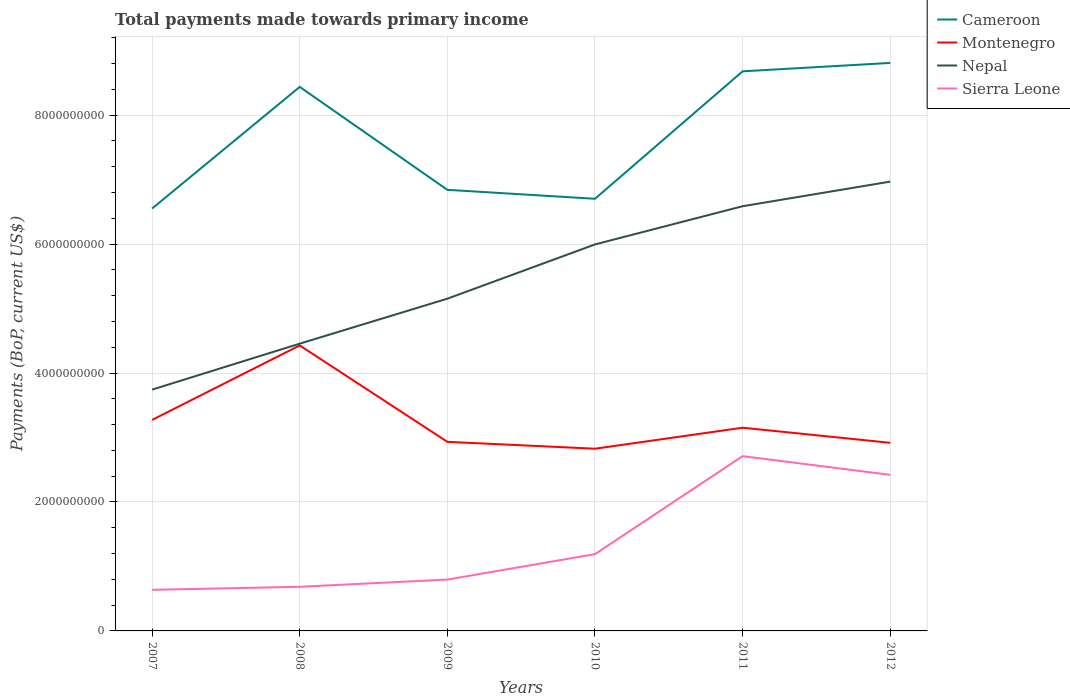How many different coloured lines are there?
Give a very brief answer. 4. Does the line corresponding to Montenegro intersect with the line corresponding to Sierra Leone?
Keep it short and to the point. No. Is the number of lines equal to the number of legend labels?
Provide a short and direct response. Yes. Across all years, what is the maximum total payments made towards primary income in Cameroon?
Keep it short and to the point. 6.55e+09. In which year was the total payments made towards primary income in Nepal maximum?
Offer a very short reply. 2007. What is the total total payments made towards primary income in Nepal in the graph?
Your answer should be compact. -6.98e+08. What is the difference between the highest and the second highest total payments made towards primary income in Montenegro?
Provide a succinct answer. 1.60e+09. Is the total payments made towards primary income in Nepal strictly greater than the total payments made towards primary income in Cameroon over the years?
Your answer should be compact. Yes. How many years are there in the graph?
Provide a succinct answer. 6. What is the difference between two consecutive major ticks on the Y-axis?
Provide a succinct answer. 2.00e+09. Are the values on the major ticks of Y-axis written in scientific E-notation?
Offer a terse response. No. Does the graph contain any zero values?
Ensure brevity in your answer.  No. Where does the legend appear in the graph?
Keep it short and to the point. Top right. What is the title of the graph?
Provide a short and direct response. Total payments made towards primary income. What is the label or title of the X-axis?
Ensure brevity in your answer.  Years. What is the label or title of the Y-axis?
Offer a very short reply. Payments (BoP, current US$). What is the Payments (BoP, current US$) of Cameroon in 2007?
Make the answer very short. 6.55e+09. What is the Payments (BoP, current US$) of Montenegro in 2007?
Keep it short and to the point. 3.27e+09. What is the Payments (BoP, current US$) of Nepal in 2007?
Make the answer very short. 3.74e+09. What is the Payments (BoP, current US$) of Sierra Leone in 2007?
Your answer should be compact. 6.37e+08. What is the Payments (BoP, current US$) in Cameroon in 2008?
Offer a very short reply. 8.44e+09. What is the Payments (BoP, current US$) in Montenegro in 2008?
Provide a short and direct response. 4.43e+09. What is the Payments (BoP, current US$) in Nepal in 2008?
Give a very brief answer. 4.46e+09. What is the Payments (BoP, current US$) of Sierra Leone in 2008?
Provide a short and direct response. 6.85e+08. What is the Payments (BoP, current US$) in Cameroon in 2009?
Offer a very short reply. 6.84e+09. What is the Payments (BoP, current US$) of Montenegro in 2009?
Make the answer very short. 2.93e+09. What is the Payments (BoP, current US$) in Nepal in 2009?
Offer a terse response. 5.15e+09. What is the Payments (BoP, current US$) in Sierra Leone in 2009?
Provide a short and direct response. 7.97e+08. What is the Payments (BoP, current US$) in Cameroon in 2010?
Offer a very short reply. 6.70e+09. What is the Payments (BoP, current US$) of Montenegro in 2010?
Your response must be concise. 2.83e+09. What is the Payments (BoP, current US$) of Nepal in 2010?
Give a very brief answer. 5.99e+09. What is the Payments (BoP, current US$) in Sierra Leone in 2010?
Provide a succinct answer. 1.19e+09. What is the Payments (BoP, current US$) of Cameroon in 2011?
Offer a very short reply. 8.68e+09. What is the Payments (BoP, current US$) in Montenegro in 2011?
Your answer should be compact. 3.15e+09. What is the Payments (BoP, current US$) in Nepal in 2011?
Make the answer very short. 6.59e+09. What is the Payments (BoP, current US$) of Sierra Leone in 2011?
Your answer should be very brief. 2.71e+09. What is the Payments (BoP, current US$) of Cameroon in 2012?
Offer a terse response. 8.81e+09. What is the Payments (BoP, current US$) of Montenegro in 2012?
Make the answer very short. 2.92e+09. What is the Payments (BoP, current US$) of Nepal in 2012?
Offer a very short reply. 6.97e+09. What is the Payments (BoP, current US$) of Sierra Leone in 2012?
Offer a very short reply. 2.42e+09. Across all years, what is the maximum Payments (BoP, current US$) of Cameroon?
Give a very brief answer. 8.81e+09. Across all years, what is the maximum Payments (BoP, current US$) in Montenegro?
Your answer should be compact. 4.43e+09. Across all years, what is the maximum Payments (BoP, current US$) of Nepal?
Offer a terse response. 6.97e+09. Across all years, what is the maximum Payments (BoP, current US$) of Sierra Leone?
Provide a short and direct response. 2.71e+09. Across all years, what is the minimum Payments (BoP, current US$) of Cameroon?
Provide a short and direct response. 6.55e+09. Across all years, what is the minimum Payments (BoP, current US$) of Montenegro?
Make the answer very short. 2.83e+09. Across all years, what is the minimum Payments (BoP, current US$) in Nepal?
Keep it short and to the point. 3.74e+09. Across all years, what is the minimum Payments (BoP, current US$) of Sierra Leone?
Offer a terse response. 6.37e+08. What is the total Payments (BoP, current US$) in Cameroon in the graph?
Make the answer very short. 4.60e+1. What is the total Payments (BoP, current US$) in Montenegro in the graph?
Give a very brief answer. 1.95e+1. What is the total Payments (BoP, current US$) of Nepal in the graph?
Offer a very short reply. 3.29e+1. What is the total Payments (BoP, current US$) in Sierra Leone in the graph?
Your answer should be compact. 8.44e+09. What is the difference between the Payments (BoP, current US$) of Cameroon in 2007 and that in 2008?
Your answer should be compact. -1.89e+09. What is the difference between the Payments (BoP, current US$) of Montenegro in 2007 and that in 2008?
Give a very brief answer. -1.16e+09. What is the difference between the Payments (BoP, current US$) in Nepal in 2007 and that in 2008?
Offer a terse response. -7.13e+08. What is the difference between the Payments (BoP, current US$) in Sierra Leone in 2007 and that in 2008?
Keep it short and to the point. -4.72e+07. What is the difference between the Payments (BoP, current US$) in Cameroon in 2007 and that in 2009?
Your answer should be compact. -2.90e+08. What is the difference between the Payments (BoP, current US$) in Montenegro in 2007 and that in 2009?
Your answer should be very brief. 3.40e+08. What is the difference between the Payments (BoP, current US$) of Nepal in 2007 and that in 2009?
Ensure brevity in your answer.  -1.41e+09. What is the difference between the Payments (BoP, current US$) in Sierra Leone in 2007 and that in 2009?
Your answer should be very brief. -1.59e+08. What is the difference between the Payments (BoP, current US$) in Cameroon in 2007 and that in 2010?
Ensure brevity in your answer.  -1.51e+08. What is the difference between the Payments (BoP, current US$) in Montenegro in 2007 and that in 2010?
Give a very brief answer. 4.46e+08. What is the difference between the Payments (BoP, current US$) in Nepal in 2007 and that in 2010?
Your answer should be compact. -2.25e+09. What is the difference between the Payments (BoP, current US$) of Sierra Leone in 2007 and that in 2010?
Offer a terse response. -5.54e+08. What is the difference between the Payments (BoP, current US$) in Cameroon in 2007 and that in 2011?
Your response must be concise. -2.13e+09. What is the difference between the Payments (BoP, current US$) in Montenegro in 2007 and that in 2011?
Make the answer very short. 1.21e+08. What is the difference between the Payments (BoP, current US$) of Nepal in 2007 and that in 2011?
Your answer should be very brief. -2.84e+09. What is the difference between the Payments (BoP, current US$) of Sierra Leone in 2007 and that in 2011?
Your response must be concise. -2.07e+09. What is the difference between the Payments (BoP, current US$) of Cameroon in 2007 and that in 2012?
Provide a succinct answer. -2.26e+09. What is the difference between the Payments (BoP, current US$) in Montenegro in 2007 and that in 2012?
Your answer should be compact. 3.55e+08. What is the difference between the Payments (BoP, current US$) of Nepal in 2007 and that in 2012?
Provide a succinct answer. -3.23e+09. What is the difference between the Payments (BoP, current US$) in Sierra Leone in 2007 and that in 2012?
Provide a succinct answer. -1.78e+09. What is the difference between the Payments (BoP, current US$) in Cameroon in 2008 and that in 2009?
Your answer should be very brief. 1.60e+09. What is the difference between the Payments (BoP, current US$) of Montenegro in 2008 and that in 2009?
Your response must be concise. 1.50e+09. What is the difference between the Payments (BoP, current US$) of Nepal in 2008 and that in 2009?
Your answer should be very brief. -6.98e+08. What is the difference between the Payments (BoP, current US$) of Sierra Leone in 2008 and that in 2009?
Offer a terse response. -1.12e+08. What is the difference between the Payments (BoP, current US$) in Cameroon in 2008 and that in 2010?
Make the answer very short. 1.74e+09. What is the difference between the Payments (BoP, current US$) of Montenegro in 2008 and that in 2010?
Ensure brevity in your answer.  1.60e+09. What is the difference between the Payments (BoP, current US$) of Nepal in 2008 and that in 2010?
Your answer should be compact. -1.54e+09. What is the difference between the Payments (BoP, current US$) of Sierra Leone in 2008 and that in 2010?
Offer a very short reply. -5.07e+08. What is the difference between the Payments (BoP, current US$) in Cameroon in 2008 and that in 2011?
Provide a short and direct response. -2.42e+08. What is the difference between the Payments (BoP, current US$) in Montenegro in 2008 and that in 2011?
Provide a succinct answer. 1.28e+09. What is the difference between the Payments (BoP, current US$) in Nepal in 2008 and that in 2011?
Ensure brevity in your answer.  -2.13e+09. What is the difference between the Payments (BoP, current US$) of Sierra Leone in 2008 and that in 2011?
Your answer should be very brief. -2.03e+09. What is the difference between the Payments (BoP, current US$) of Cameroon in 2008 and that in 2012?
Ensure brevity in your answer.  -3.72e+08. What is the difference between the Payments (BoP, current US$) of Montenegro in 2008 and that in 2012?
Keep it short and to the point. 1.51e+09. What is the difference between the Payments (BoP, current US$) of Nepal in 2008 and that in 2012?
Give a very brief answer. -2.51e+09. What is the difference between the Payments (BoP, current US$) in Sierra Leone in 2008 and that in 2012?
Offer a very short reply. -1.74e+09. What is the difference between the Payments (BoP, current US$) in Cameroon in 2009 and that in 2010?
Your answer should be compact. 1.39e+08. What is the difference between the Payments (BoP, current US$) in Montenegro in 2009 and that in 2010?
Provide a succinct answer. 1.07e+08. What is the difference between the Payments (BoP, current US$) of Nepal in 2009 and that in 2010?
Your answer should be very brief. -8.42e+08. What is the difference between the Payments (BoP, current US$) in Sierra Leone in 2009 and that in 2010?
Offer a terse response. -3.95e+08. What is the difference between the Payments (BoP, current US$) of Cameroon in 2009 and that in 2011?
Provide a succinct answer. -1.84e+09. What is the difference between the Payments (BoP, current US$) of Montenegro in 2009 and that in 2011?
Provide a succinct answer. -2.19e+08. What is the difference between the Payments (BoP, current US$) of Nepal in 2009 and that in 2011?
Keep it short and to the point. -1.43e+09. What is the difference between the Payments (BoP, current US$) of Sierra Leone in 2009 and that in 2011?
Give a very brief answer. -1.91e+09. What is the difference between the Payments (BoP, current US$) in Cameroon in 2009 and that in 2012?
Your response must be concise. -1.97e+09. What is the difference between the Payments (BoP, current US$) in Montenegro in 2009 and that in 2012?
Offer a very short reply. 1.51e+07. What is the difference between the Payments (BoP, current US$) of Nepal in 2009 and that in 2012?
Keep it short and to the point. -1.82e+09. What is the difference between the Payments (BoP, current US$) of Sierra Leone in 2009 and that in 2012?
Offer a very short reply. -1.62e+09. What is the difference between the Payments (BoP, current US$) of Cameroon in 2010 and that in 2011?
Keep it short and to the point. -1.98e+09. What is the difference between the Payments (BoP, current US$) in Montenegro in 2010 and that in 2011?
Give a very brief answer. -3.26e+08. What is the difference between the Payments (BoP, current US$) of Nepal in 2010 and that in 2011?
Ensure brevity in your answer.  -5.93e+08. What is the difference between the Payments (BoP, current US$) of Sierra Leone in 2010 and that in 2011?
Offer a very short reply. -1.52e+09. What is the difference between the Payments (BoP, current US$) in Cameroon in 2010 and that in 2012?
Your answer should be very brief. -2.11e+09. What is the difference between the Payments (BoP, current US$) in Montenegro in 2010 and that in 2012?
Keep it short and to the point. -9.16e+07. What is the difference between the Payments (BoP, current US$) in Nepal in 2010 and that in 2012?
Ensure brevity in your answer.  -9.74e+08. What is the difference between the Payments (BoP, current US$) of Sierra Leone in 2010 and that in 2012?
Provide a short and direct response. -1.23e+09. What is the difference between the Payments (BoP, current US$) of Cameroon in 2011 and that in 2012?
Offer a terse response. -1.30e+08. What is the difference between the Payments (BoP, current US$) in Montenegro in 2011 and that in 2012?
Keep it short and to the point. 2.34e+08. What is the difference between the Payments (BoP, current US$) of Nepal in 2011 and that in 2012?
Give a very brief answer. -3.82e+08. What is the difference between the Payments (BoP, current US$) of Sierra Leone in 2011 and that in 2012?
Make the answer very short. 2.90e+08. What is the difference between the Payments (BoP, current US$) of Cameroon in 2007 and the Payments (BoP, current US$) of Montenegro in 2008?
Your response must be concise. 2.12e+09. What is the difference between the Payments (BoP, current US$) of Cameroon in 2007 and the Payments (BoP, current US$) of Nepal in 2008?
Offer a very short reply. 2.10e+09. What is the difference between the Payments (BoP, current US$) in Cameroon in 2007 and the Payments (BoP, current US$) in Sierra Leone in 2008?
Give a very brief answer. 5.87e+09. What is the difference between the Payments (BoP, current US$) of Montenegro in 2007 and the Payments (BoP, current US$) of Nepal in 2008?
Give a very brief answer. -1.18e+09. What is the difference between the Payments (BoP, current US$) in Montenegro in 2007 and the Payments (BoP, current US$) in Sierra Leone in 2008?
Provide a short and direct response. 2.59e+09. What is the difference between the Payments (BoP, current US$) of Nepal in 2007 and the Payments (BoP, current US$) of Sierra Leone in 2008?
Make the answer very short. 3.06e+09. What is the difference between the Payments (BoP, current US$) of Cameroon in 2007 and the Payments (BoP, current US$) of Montenegro in 2009?
Ensure brevity in your answer.  3.62e+09. What is the difference between the Payments (BoP, current US$) in Cameroon in 2007 and the Payments (BoP, current US$) in Nepal in 2009?
Keep it short and to the point. 1.40e+09. What is the difference between the Payments (BoP, current US$) of Cameroon in 2007 and the Payments (BoP, current US$) of Sierra Leone in 2009?
Provide a succinct answer. 5.76e+09. What is the difference between the Payments (BoP, current US$) of Montenegro in 2007 and the Payments (BoP, current US$) of Nepal in 2009?
Give a very brief answer. -1.88e+09. What is the difference between the Payments (BoP, current US$) in Montenegro in 2007 and the Payments (BoP, current US$) in Sierra Leone in 2009?
Provide a short and direct response. 2.48e+09. What is the difference between the Payments (BoP, current US$) of Nepal in 2007 and the Payments (BoP, current US$) of Sierra Leone in 2009?
Your response must be concise. 2.95e+09. What is the difference between the Payments (BoP, current US$) in Cameroon in 2007 and the Payments (BoP, current US$) in Montenegro in 2010?
Offer a terse response. 3.73e+09. What is the difference between the Payments (BoP, current US$) of Cameroon in 2007 and the Payments (BoP, current US$) of Nepal in 2010?
Ensure brevity in your answer.  5.57e+08. What is the difference between the Payments (BoP, current US$) of Cameroon in 2007 and the Payments (BoP, current US$) of Sierra Leone in 2010?
Offer a terse response. 5.36e+09. What is the difference between the Payments (BoP, current US$) in Montenegro in 2007 and the Payments (BoP, current US$) in Nepal in 2010?
Ensure brevity in your answer.  -2.72e+09. What is the difference between the Payments (BoP, current US$) in Montenegro in 2007 and the Payments (BoP, current US$) in Sierra Leone in 2010?
Your answer should be compact. 2.08e+09. What is the difference between the Payments (BoP, current US$) of Nepal in 2007 and the Payments (BoP, current US$) of Sierra Leone in 2010?
Provide a short and direct response. 2.55e+09. What is the difference between the Payments (BoP, current US$) of Cameroon in 2007 and the Payments (BoP, current US$) of Montenegro in 2011?
Offer a terse response. 3.40e+09. What is the difference between the Payments (BoP, current US$) of Cameroon in 2007 and the Payments (BoP, current US$) of Nepal in 2011?
Provide a succinct answer. -3.59e+07. What is the difference between the Payments (BoP, current US$) of Cameroon in 2007 and the Payments (BoP, current US$) of Sierra Leone in 2011?
Provide a short and direct response. 3.84e+09. What is the difference between the Payments (BoP, current US$) in Montenegro in 2007 and the Payments (BoP, current US$) in Nepal in 2011?
Your response must be concise. -3.31e+09. What is the difference between the Payments (BoP, current US$) of Montenegro in 2007 and the Payments (BoP, current US$) of Sierra Leone in 2011?
Make the answer very short. 5.62e+08. What is the difference between the Payments (BoP, current US$) in Nepal in 2007 and the Payments (BoP, current US$) in Sierra Leone in 2011?
Provide a succinct answer. 1.03e+09. What is the difference between the Payments (BoP, current US$) of Cameroon in 2007 and the Payments (BoP, current US$) of Montenegro in 2012?
Offer a terse response. 3.63e+09. What is the difference between the Payments (BoP, current US$) in Cameroon in 2007 and the Payments (BoP, current US$) in Nepal in 2012?
Make the answer very short. -4.18e+08. What is the difference between the Payments (BoP, current US$) in Cameroon in 2007 and the Payments (BoP, current US$) in Sierra Leone in 2012?
Make the answer very short. 4.13e+09. What is the difference between the Payments (BoP, current US$) in Montenegro in 2007 and the Payments (BoP, current US$) in Nepal in 2012?
Your response must be concise. -3.70e+09. What is the difference between the Payments (BoP, current US$) of Montenegro in 2007 and the Payments (BoP, current US$) of Sierra Leone in 2012?
Give a very brief answer. 8.52e+08. What is the difference between the Payments (BoP, current US$) in Nepal in 2007 and the Payments (BoP, current US$) in Sierra Leone in 2012?
Your answer should be very brief. 1.32e+09. What is the difference between the Payments (BoP, current US$) in Cameroon in 2008 and the Payments (BoP, current US$) in Montenegro in 2009?
Offer a terse response. 5.51e+09. What is the difference between the Payments (BoP, current US$) of Cameroon in 2008 and the Payments (BoP, current US$) of Nepal in 2009?
Offer a very short reply. 3.29e+09. What is the difference between the Payments (BoP, current US$) in Cameroon in 2008 and the Payments (BoP, current US$) in Sierra Leone in 2009?
Your answer should be very brief. 7.64e+09. What is the difference between the Payments (BoP, current US$) of Montenegro in 2008 and the Payments (BoP, current US$) of Nepal in 2009?
Keep it short and to the point. -7.25e+08. What is the difference between the Payments (BoP, current US$) in Montenegro in 2008 and the Payments (BoP, current US$) in Sierra Leone in 2009?
Your answer should be very brief. 3.63e+09. What is the difference between the Payments (BoP, current US$) in Nepal in 2008 and the Payments (BoP, current US$) in Sierra Leone in 2009?
Provide a short and direct response. 3.66e+09. What is the difference between the Payments (BoP, current US$) of Cameroon in 2008 and the Payments (BoP, current US$) of Montenegro in 2010?
Offer a terse response. 5.61e+09. What is the difference between the Payments (BoP, current US$) in Cameroon in 2008 and the Payments (BoP, current US$) in Nepal in 2010?
Ensure brevity in your answer.  2.44e+09. What is the difference between the Payments (BoP, current US$) in Cameroon in 2008 and the Payments (BoP, current US$) in Sierra Leone in 2010?
Ensure brevity in your answer.  7.25e+09. What is the difference between the Payments (BoP, current US$) in Montenegro in 2008 and the Payments (BoP, current US$) in Nepal in 2010?
Your response must be concise. -1.57e+09. What is the difference between the Payments (BoP, current US$) in Montenegro in 2008 and the Payments (BoP, current US$) in Sierra Leone in 2010?
Keep it short and to the point. 3.24e+09. What is the difference between the Payments (BoP, current US$) in Nepal in 2008 and the Payments (BoP, current US$) in Sierra Leone in 2010?
Provide a short and direct response. 3.26e+09. What is the difference between the Payments (BoP, current US$) in Cameroon in 2008 and the Payments (BoP, current US$) in Montenegro in 2011?
Make the answer very short. 5.29e+09. What is the difference between the Payments (BoP, current US$) of Cameroon in 2008 and the Payments (BoP, current US$) of Nepal in 2011?
Your answer should be very brief. 1.85e+09. What is the difference between the Payments (BoP, current US$) in Cameroon in 2008 and the Payments (BoP, current US$) in Sierra Leone in 2011?
Give a very brief answer. 5.73e+09. What is the difference between the Payments (BoP, current US$) of Montenegro in 2008 and the Payments (BoP, current US$) of Nepal in 2011?
Your answer should be very brief. -2.16e+09. What is the difference between the Payments (BoP, current US$) in Montenegro in 2008 and the Payments (BoP, current US$) in Sierra Leone in 2011?
Provide a short and direct response. 1.72e+09. What is the difference between the Payments (BoP, current US$) in Nepal in 2008 and the Payments (BoP, current US$) in Sierra Leone in 2011?
Give a very brief answer. 1.74e+09. What is the difference between the Payments (BoP, current US$) of Cameroon in 2008 and the Payments (BoP, current US$) of Montenegro in 2012?
Offer a very short reply. 5.52e+09. What is the difference between the Payments (BoP, current US$) of Cameroon in 2008 and the Payments (BoP, current US$) of Nepal in 2012?
Your response must be concise. 1.47e+09. What is the difference between the Payments (BoP, current US$) in Cameroon in 2008 and the Payments (BoP, current US$) in Sierra Leone in 2012?
Offer a very short reply. 6.02e+09. What is the difference between the Payments (BoP, current US$) of Montenegro in 2008 and the Payments (BoP, current US$) of Nepal in 2012?
Provide a succinct answer. -2.54e+09. What is the difference between the Payments (BoP, current US$) in Montenegro in 2008 and the Payments (BoP, current US$) in Sierra Leone in 2012?
Offer a terse response. 2.01e+09. What is the difference between the Payments (BoP, current US$) of Nepal in 2008 and the Payments (BoP, current US$) of Sierra Leone in 2012?
Provide a succinct answer. 2.03e+09. What is the difference between the Payments (BoP, current US$) in Cameroon in 2009 and the Payments (BoP, current US$) in Montenegro in 2010?
Keep it short and to the point. 4.02e+09. What is the difference between the Payments (BoP, current US$) of Cameroon in 2009 and the Payments (BoP, current US$) of Nepal in 2010?
Offer a terse response. 8.47e+08. What is the difference between the Payments (BoP, current US$) of Cameroon in 2009 and the Payments (BoP, current US$) of Sierra Leone in 2010?
Provide a short and direct response. 5.65e+09. What is the difference between the Payments (BoP, current US$) in Montenegro in 2009 and the Payments (BoP, current US$) in Nepal in 2010?
Provide a succinct answer. -3.06e+09. What is the difference between the Payments (BoP, current US$) of Montenegro in 2009 and the Payments (BoP, current US$) of Sierra Leone in 2010?
Provide a short and direct response. 1.74e+09. What is the difference between the Payments (BoP, current US$) in Nepal in 2009 and the Payments (BoP, current US$) in Sierra Leone in 2010?
Provide a short and direct response. 3.96e+09. What is the difference between the Payments (BoP, current US$) in Cameroon in 2009 and the Payments (BoP, current US$) in Montenegro in 2011?
Offer a terse response. 3.69e+09. What is the difference between the Payments (BoP, current US$) of Cameroon in 2009 and the Payments (BoP, current US$) of Nepal in 2011?
Give a very brief answer. 2.54e+08. What is the difference between the Payments (BoP, current US$) in Cameroon in 2009 and the Payments (BoP, current US$) in Sierra Leone in 2011?
Offer a terse response. 4.13e+09. What is the difference between the Payments (BoP, current US$) in Montenegro in 2009 and the Payments (BoP, current US$) in Nepal in 2011?
Provide a succinct answer. -3.65e+09. What is the difference between the Payments (BoP, current US$) in Montenegro in 2009 and the Payments (BoP, current US$) in Sierra Leone in 2011?
Your response must be concise. 2.22e+08. What is the difference between the Payments (BoP, current US$) of Nepal in 2009 and the Payments (BoP, current US$) of Sierra Leone in 2011?
Provide a short and direct response. 2.44e+09. What is the difference between the Payments (BoP, current US$) of Cameroon in 2009 and the Payments (BoP, current US$) of Montenegro in 2012?
Make the answer very short. 3.92e+09. What is the difference between the Payments (BoP, current US$) of Cameroon in 2009 and the Payments (BoP, current US$) of Nepal in 2012?
Your answer should be compact. -1.28e+08. What is the difference between the Payments (BoP, current US$) of Cameroon in 2009 and the Payments (BoP, current US$) of Sierra Leone in 2012?
Your answer should be very brief. 4.42e+09. What is the difference between the Payments (BoP, current US$) of Montenegro in 2009 and the Payments (BoP, current US$) of Nepal in 2012?
Your answer should be very brief. -4.04e+09. What is the difference between the Payments (BoP, current US$) in Montenegro in 2009 and the Payments (BoP, current US$) in Sierra Leone in 2012?
Provide a short and direct response. 5.12e+08. What is the difference between the Payments (BoP, current US$) in Nepal in 2009 and the Payments (BoP, current US$) in Sierra Leone in 2012?
Your answer should be very brief. 2.73e+09. What is the difference between the Payments (BoP, current US$) of Cameroon in 2010 and the Payments (BoP, current US$) of Montenegro in 2011?
Provide a short and direct response. 3.55e+09. What is the difference between the Payments (BoP, current US$) in Cameroon in 2010 and the Payments (BoP, current US$) in Nepal in 2011?
Make the answer very short. 1.16e+08. What is the difference between the Payments (BoP, current US$) in Cameroon in 2010 and the Payments (BoP, current US$) in Sierra Leone in 2011?
Provide a succinct answer. 3.99e+09. What is the difference between the Payments (BoP, current US$) of Montenegro in 2010 and the Payments (BoP, current US$) of Nepal in 2011?
Make the answer very short. -3.76e+09. What is the difference between the Payments (BoP, current US$) of Montenegro in 2010 and the Payments (BoP, current US$) of Sierra Leone in 2011?
Offer a very short reply. 1.15e+08. What is the difference between the Payments (BoP, current US$) in Nepal in 2010 and the Payments (BoP, current US$) in Sierra Leone in 2011?
Your response must be concise. 3.28e+09. What is the difference between the Payments (BoP, current US$) in Cameroon in 2010 and the Payments (BoP, current US$) in Montenegro in 2012?
Provide a short and direct response. 3.79e+09. What is the difference between the Payments (BoP, current US$) in Cameroon in 2010 and the Payments (BoP, current US$) in Nepal in 2012?
Provide a short and direct response. -2.66e+08. What is the difference between the Payments (BoP, current US$) in Cameroon in 2010 and the Payments (BoP, current US$) in Sierra Leone in 2012?
Your response must be concise. 4.28e+09. What is the difference between the Payments (BoP, current US$) of Montenegro in 2010 and the Payments (BoP, current US$) of Nepal in 2012?
Ensure brevity in your answer.  -4.14e+09. What is the difference between the Payments (BoP, current US$) in Montenegro in 2010 and the Payments (BoP, current US$) in Sierra Leone in 2012?
Keep it short and to the point. 4.05e+08. What is the difference between the Payments (BoP, current US$) of Nepal in 2010 and the Payments (BoP, current US$) of Sierra Leone in 2012?
Make the answer very short. 3.57e+09. What is the difference between the Payments (BoP, current US$) of Cameroon in 2011 and the Payments (BoP, current US$) of Montenegro in 2012?
Provide a succinct answer. 5.76e+09. What is the difference between the Payments (BoP, current US$) in Cameroon in 2011 and the Payments (BoP, current US$) in Nepal in 2012?
Keep it short and to the point. 1.71e+09. What is the difference between the Payments (BoP, current US$) in Cameroon in 2011 and the Payments (BoP, current US$) in Sierra Leone in 2012?
Provide a succinct answer. 6.26e+09. What is the difference between the Payments (BoP, current US$) of Montenegro in 2011 and the Payments (BoP, current US$) of Nepal in 2012?
Your answer should be compact. -3.82e+09. What is the difference between the Payments (BoP, current US$) in Montenegro in 2011 and the Payments (BoP, current US$) in Sierra Leone in 2012?
Provide a short and direct response. 7.31e+08. What is the difference between the Payments (BoP, current US$) in Nepal in 2011 and the Payments (BoP, current US$) in Sierra Leone in 2012?
Your response must be concise. 4.17e+09. What is the average Payments (BoP, current US$) of Cameroon per year?
Offer a very short reply. 7.67e+09. What is the average Payments (BoP, current US$) of Montenegro per year?
Your response must be concise. 3.26e+09. What is the average Payments (BoP, current US$) in Nepal per year?
Your answer should be compact. 5.48e+09. What is the average Payments (BoP, current US$) of Sierra Leone per year?
Offer a very short reply. 1.41e+09. In the year 2007, what is the difference between the Payments (BoP, current US$) in Cameroon and Payments (BoP, current US$) in Montenegro?
Your answer should be very brief. 3.28e+09. In the year 2007, what is the difference between the Payments (BoP, current US$) of Cameroon and Payments (BoP, current US$) of Nepal?
Offer a terse response. 2.81e+09. In the year 2007, what is the difference between the Payments (BoP, current US$) in Cameroon and Payments (BoP, current US$) in Sierra Leone?
Offer a very short reply. 5.91e+09. In the year 2007, what is the difference between the Payments (BoP, current US$) of Montenegro and Payments (BoP, current US$) of Nepal?
Ensure brevity in your answer.  -4.70e+08. In the year 2007, what is the difference between the Payments (BoP, current US$) of Montenegro and Payments (BoP, current US$) of Sierra Leone?
Your answer should be compact. 2.64e+09. In the year 2007, what is the difference between the Payments (BoP, current US$) in Nepal and Payments (BoP, current US$) in Sierra Leone?
Provide a short and direct response. 3.11e+09. In the year 2008, what is the difference between the Payments (BoP, current US$) in Cameroon and Payments (BoP, current US$) in Montenegro?
Your answer should be very brief. 4.01e+09. In the year 2008, what is the difference between the Payments (BoP, current US$) of Cameroon and Payments (BoP, current US$) of Nepal?
Provide a succinct answer. 3.98e+09. In the year 2008, what is the difference between the Payments (BoP, current US$) of Cameroon and Payments (BoP, current US$) of Sierra Leone?
Your response must be concise. 7.75e+09. In the year 2008, what is the difference between the Payments (BoP, current US$) of Montenegro and Payments (BoP, current US$) of Nepal?
Give a very brief answer. -2.74e+07. In the year 2008, what is the difference between the Payments (BoP, current US$) of Montenegro and Payments (BoP, current US$) of Sierra Leone?
Provide a succinct answer. 3.74e+09. In the year 2008, what is the difference between the Payments (BoP, current US$) of Nepal and Payments (BoP, current US$) of Sierra Leone?
Keep it short and to the point. 3.77e+09. In the year 2009, what is the difference between the Payments (BoP, current US$) of Cameroon and Payments (BoP, current US$) of Montenegro?
Provide a short and direct response. 3.91e+09. In the year 2009, what is the difference between the Payments (BoP, current US$) of Cameroon and Payments (BoP, current US$) of Nepal?
Provide a short and direct response. 1.69e+09. In the year 2009, what is the difference between the Payments (BoP, current US$) in Cameroon and Payments (BoP, current US$) in Sierra Leone?
Keep it short and to the point. 6.05e+09. In the year 2009, what is the difference between the Payments (BoP, current US$) in Montenegro and Payments (BoP, current US$) in Nepal?
Your answer should be very brief. -2.22e+09. In the year 2009, what is the difference between the Payments (BoP, current US$) of Montenegro and Payments (BoP, current US$) of Sierra Leone?
Provide a succinct answer. 2.14e+09. In the year 2009, what is the difference between the Payments (BoP, current US$) in Nepal and Payments (BoP, current US$) in Sierra Leone?
Your answer should be compact. 4.36e+09. In the year 2010, what is the difference between the Payments (BoP, current US$) in Cameroon and Payments (BoP, current US$) in Montenegro?
Offer a very short reply. 3.88e+09. In the year 2010, what is the difference between the Payments (BoP, current US$) in Cameroon and Payments (BoP, current US$) in Nepal?
Provide a succinct answer. 7.08e+08. In the year 2010, what is the difference between the Payments (BoP, current US$) in Cameroon and Payments (BoP, current US$) in Sierra Leone?
Keep it short and to the point. 5.51e+09. In the year 2010, what is the difference between the Payments (BoP, current US$) in Montenegro and Payments (BoP, current US$) in Nepal?
Ensure brevity in your answer.  -3.17e+09. In the year 2010, what is the difference between the Payments (BoP, current US$) of Montenegro and Payments (BoP, current US$) of Sierra Leone?
Keep it short and to the point. 1.64e+09. In the year 2010, what is the difference between the Payments (BoP, current US$) of Nepal and Payments (BoP, current US$) of Sierra Leone?
Your answer should be compact. 4.80e+09. In the year 2011, what is the difference between the Payments (BoP, current US$) in Cameroon and Payments (BoP, current US$) in Montenegro?
Ensure brevity in your answer.  5.53e+09. In the year 2011, what is the difference between the Payments (BoP, current US$) in Cameroon and Payments (BoP, current US$) in Nepal?
Offer a terse response. 2.09e+09. In the year 2011, what is the difference between the Payments (BoP, current US$) of Cameroon and Payments (BoP, current US$) of Sierra Leone?
Your answer should be very brief. 5.97e+09. In the year 2011, what is the difference between the Payments (BoP, current US$) in Montenegro and Payments (BoP, current US$) in Nepal?
Give a very brief answer. -3.44e+09. In the year 2011, what is the difference between the Payments (BoP, current US$) in Montenegro and Payments (BoP, current US$) in Sierra Leone?
Offer a terse response. 4.41e+08. In the year 2011, what is the difference between the Payments (BoP, current US$) in Nepal and Payments (BoP, current US$) in Sierra Leone?
Provide a short and direct response. 3.88e+09. In the year 2012, what is the difference between the Payments (BoP, current US$) of Cameroon and Payments (BoP, current US$) of Montenegro?
Make the answer very short. 5.89e+09. In the year 2012, what is the difference between the Payments (BoP, current US$) of Cameroon and Payments (BoP, current US$) of Nepal?
Provide a short and direct response. 1.84e+09. In the year 2012, what is the difference between the Payments (BoP, current US$) in Cameroon and Payments (BoP, current US$) in Sierra Leone?
Provide a short and direct response. 6.39e+09. In the year 2012, what is the difference between the Payments (BoP, current US$) of Montenegro and Payments (BoP, current US$) of Nepal?
Your answer should be very brief. -4.05e+09. In the year 2012, what is the difference between the Payments (BoP, current US$) of Montenegro and Payments (BoP, current US$) of Sierra Leone?
Offer a terse response. 4.97e+08. In the year 2012, what is the difference between the Payments (BoP, current US$) of Nepal and Payments (BoP, current US$) of Sierra Leone?
Provide a short and direct response. 4.55e+09. What is the ratio of the Payments (BoP, current US$) of Cameroon in 2007 to that in 2008?
Your response must be concise. 0.78. What is the ratio of the Payments (BoP, current US$) in Montenegro in 2007 to that in 2008?
Offer a very short reply. 0.74. What is the ratio of the Payments (BoP, current US$) of Nepal in 2007 to that in 2008?
Make the answer very short. 0.84. What is the ratio of the Payments (BoP, current US$) in Cameroon in 2007 to that in 2009?
Give a very brief answer. 0.96. What is the ratio of the Payments (BoP, current US$) in Montenegro in 2007 to that in 2009?
Provide a succinct answer. 1.12. What is the ratio of the Payments (BoP, current US$) of Nepal in 2007 to that in 2009?
Keep it short and to the point. 0.73. What is the ratio of the Payments (BoP, current US$) in Sierra Leone in 2007 to that in 2009?
Provide a succinct answer. 0.8. What is the ratio of the Payments (BoP, current US$) of Cameroon in 2007 to that in 2010?
Offer a very short reply. 0.98. What is the ratio of the Payments (BoP, current US$) of Montenegro in 2007 to that in 2010?
Offer a terse response. 1.16. What is the ratio of the Payments (BoP, current US$) in Nepal in 2007 to that in 2010?
Your answer should be compact. 0.62. What is the ratio of the Payments (BoP, current US$) of Sierra Leone in 2007 to that in 2010?
Your response must be concise. 0.54. What is the ratio of the Payments (BoP, current US$) of Cameroon in 2007 to that in 2011?
Ensure brevity in your answer.  0.75. What is the ratio of the Payments (BoP, current US$) of Montenegro in 2007 to that in 2011?
Your response must be concise. 1.04. What is the ratio of the Payments (BoP, current US$) of Nepal in 2007 to that in 2011?
Give a very brief answer. 0.57. What is the ratio of the Payments (BoP, current US$) in Sierra Leone in 2007 to that in 2011?
Keep it short and to the point. 0.24. What is the ratio of the Payments (BoP, current US$) of Cameroon in 2007 to that in 2012?
Provide a succinct answer. 0.74. What is the ratio of the Payments (BoP, current US$) in Montenegro in 2007 to that in 2012?
Ensure brevity in your answer.  1.12. What is the ratio of the Payments (BoP, current US$) in Nepal in 2007 to that in 2012?
Ensure brevity in your answer.  0.54. What is the ratio of the Payments (BoP, current US$) of Sierra Leone in 2007 to that in 2012?
Your answer should be compact. 0.26. What is the ratio of the Payments (BoP, current US$) of Cameroon in 2008 to that in 2009?
Provide a succinct answer. 1.23. What is the ratio of the Payments (BoP, current US$) in Montenegro in 2008 to that in 2009?
Your answer should be very brief. 1.51. What is the ratio of the Payments (BoP, current US$) of Nepal in 2008 to that in 2009?
Your answer should be compact. 0.86. What is the ratio of the Payments (BoP, current US$) in Sierra Leone in 2008 to that in 2009?
Provide a succinct answer. 0.86. What is the ratio of the Payments (BoP, current US$) of Cameroon in 2008 to that in 2010?
Keep it short and to the point. 1.26. What is the ratio of the Payments (BoP, current US$) of Montenegro in 2008 to that in 2010?
Your response must be concise. 1.57. What is the ratio of the Payments (BoP, current US$) of Nepal in 2008 to that in 2010?
Your answer should be very brief. 0.74. What is the ratio of the Payments (BoP, current US$) in Sierra Leone in 2008 to that in 2010?
Keep it short and to the point. 0.57. What is the ratio of the Payments (BoP, current US$) of Cameroon in 2008 to that in 2011?
Ensure brevity in your answer.  0.97. What is the ratio of the Payments (BoP, current US$) in Montenegro in 2008 to that in 2011?
Your answer should be compact. 1.4. What is the ratio of the Payments (BoP, current US$) of Nepal in 2008 to that in 2011?
Your answer should be very brief. 0.68. What is the ratio of the Payments (BoP, current US$) in Sierra Leone in 2008 to that in 2011?
Your response must be concise. 0.25. What is the ratio of the Payments (BoP, current US$) of Cameroon in 2008 to that in 2012?
Provide a succinct answer. 0.96. What is the ratio of the Payments (BoP, current US$) in Montenegro in 2008 to that in 2012?
Keep it short and to the point. 1.52. What is the ratio of the Payments (BoP, current US$) in Nepal in 2008 to that in 2012?
Your answer should be very brief. 0.64. What is the ratio of the Payments (BoP, current US$) of Sierra Leone in 2008 to that in 2012?
Offer a terse response. 0.28. What is the ratio of the Payments (BoP, current US$) in Cameroon in 2009 to that in 2010?
Offer a very short reply. 1.02. What is the ratio of the Payments (BoP, current US$) in Montenegro in 2009 to that in 2010?
Offer a terse response. 1.04. What is the ratio of the Payments (BoP, current US$) of Nepal in 2009 to that in 2010?
Provide a succinct answer. 0.86. What is the ratio of the Payments (BoP, current US$) in Sierra Leone in 2009 to that in 2010?
Your response must be concise. 0.67. What is the ratio of the Payments (BoP, current US$) of Cameroon in 2009 to that in 2011?
Give a very brief answer. 0.79. What is the ratio of the Payments (BoP, current US$) in Montenegro in 2009 to that in 2011?
Provide a succinct answer. 0.93. What is the ratio of the Payments (BoP, current US$) of Nepal in 2009 to that in 2011?
Keep it short and to the point. 0.78. What is the ratio of the Payments (BoP, current US$) in Sierra Leone in 2009 to that in 2011?
Your answer should be very brief. 0.29. What is the ratio of the Payments (BoP, current US$) of Cameroon in 2009 to that in 2012?
Your response must be concise. 0.78. What is the ratio of the Payments (BoP, current US$) of Montenegro in 2009 to that in 2012?
Give a very brief answer. 1.01. What is the ratio of the Payments (BoP, current US$) of Nepal in 2009 to that in 2012?
Your answer should be very brief. 0.74. What is the ratio of the Payments (BoP, current US$) in Sierra Leone in 2009 to that in 2012?
Your answer should be compact. 0.33. What is the ratio of the Payments (BoP, current US$) of Cameroon in 2010 to that in 2011?
Provide a short and direct response. 0.77. What is the ratio of the Payments (BoP, current US$) in Montenegro in 2010 to that in 2011?
Ensure brevity in your answer.  0.9. What is the ratio of the Payments (BoP, current US$) in Nepal in 2010 to that in 2011?
Provide a short and direct response. 0.91. What is the ratio of the Payments (BoP, current US$) in Sierra Leone in 2010 to that in 2011?
Give a very brief answer. 0.44. What is the ratio of the Payments (BoP, current US$) in Cameroon in 2010 to that in 2012?
Offer a very short reply. 0.76. What is the ratio of the Payments (BoP, current US$) of Montenegro in 2010 to that in 2012?
Make the answer very short. 0.97. What is the ratio of the Payments (BoP, current US$) of Nepal in 2010 to that in 2012?
Make the answer very short. 0.86. What is the ratio of the Payments (BoP, current US$) in Sierra Leone in 2010 to that in 2012?
Your answer should be compact. 0.49. What is the ratio of the Payments (BoP, current US$) of Cameroon in 2011 to that in 2012?
Ensure brevity in your answer.  0.99. What is the ratio of the Payments (BoP, current US$) of Montenegro in 2011 to that in 2012?
Your answer should be very brief. 1.08. What is the ratio of the Payments (BoP, current US$) in Nepal in 2011 to that in 2012?
Your answer should be very brief. 0.95. What is the ratio of the Payments (BoP, current US$) in Sierra Leone in 2011 to that in 2012?
Ensure brevity in your answer.  1.12. What is the difference between the highest and the second highest Payments (BoP, current US$) of Cameroon?
Offer a terse response. 1.30e+08. What is the difference between the highest and the second highest Payments (BoP, current US$) of Montenegro?
Make the answer very short. 1.16e+09. What is the difference between the highest and the second highest Payments (BoP, current US$) of Nepal?
Offer a terse response. 3.82e+08. What is the difference between the highest and the second highest Payments (BoP, current US$) in Sierra Leone?
Keep it short and to the point. 2.90e+08. What is the difference between the highest and the lowest Payments (BoP, current US$) in Cameroon?
Your answer should be very brief. 2.26e+09. What is the difference between the highest and the lowest Payments (BoP, current US$) in Montenegro?
Make the answer very short. 1.60e+09. What is the difference between the highest and the lowest Payments (BoP, current US$) of Nepal?
Ensure brevity in your answer.  3.23e+09. What is the difference between the highest and the lowest Payments (BoP, current US$) in Sierra Leone?
Offer a very short reply. 2.07e+09. 